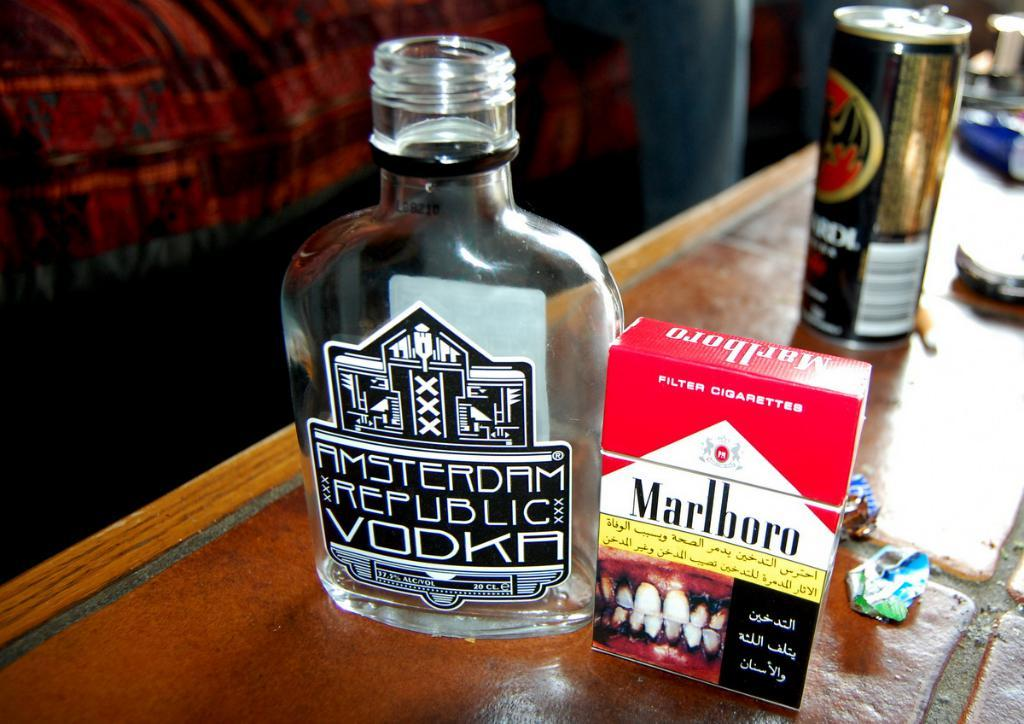<image>
Summarize the visual content of the image. A bottle of Amsterdam Republic vodka sits next to a pack of Marlboros. 